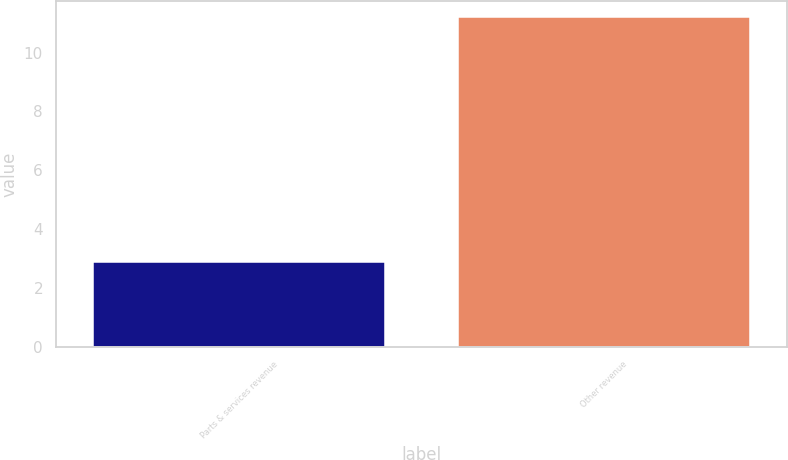Convert chart. <chart><loc_0><loc_0><loc_500><loc_500><bar_chart><fcel>Parts & services revenue<fcel>Other revenue<nl><fcel>2.9<fcel>11.2<nl></chart> 